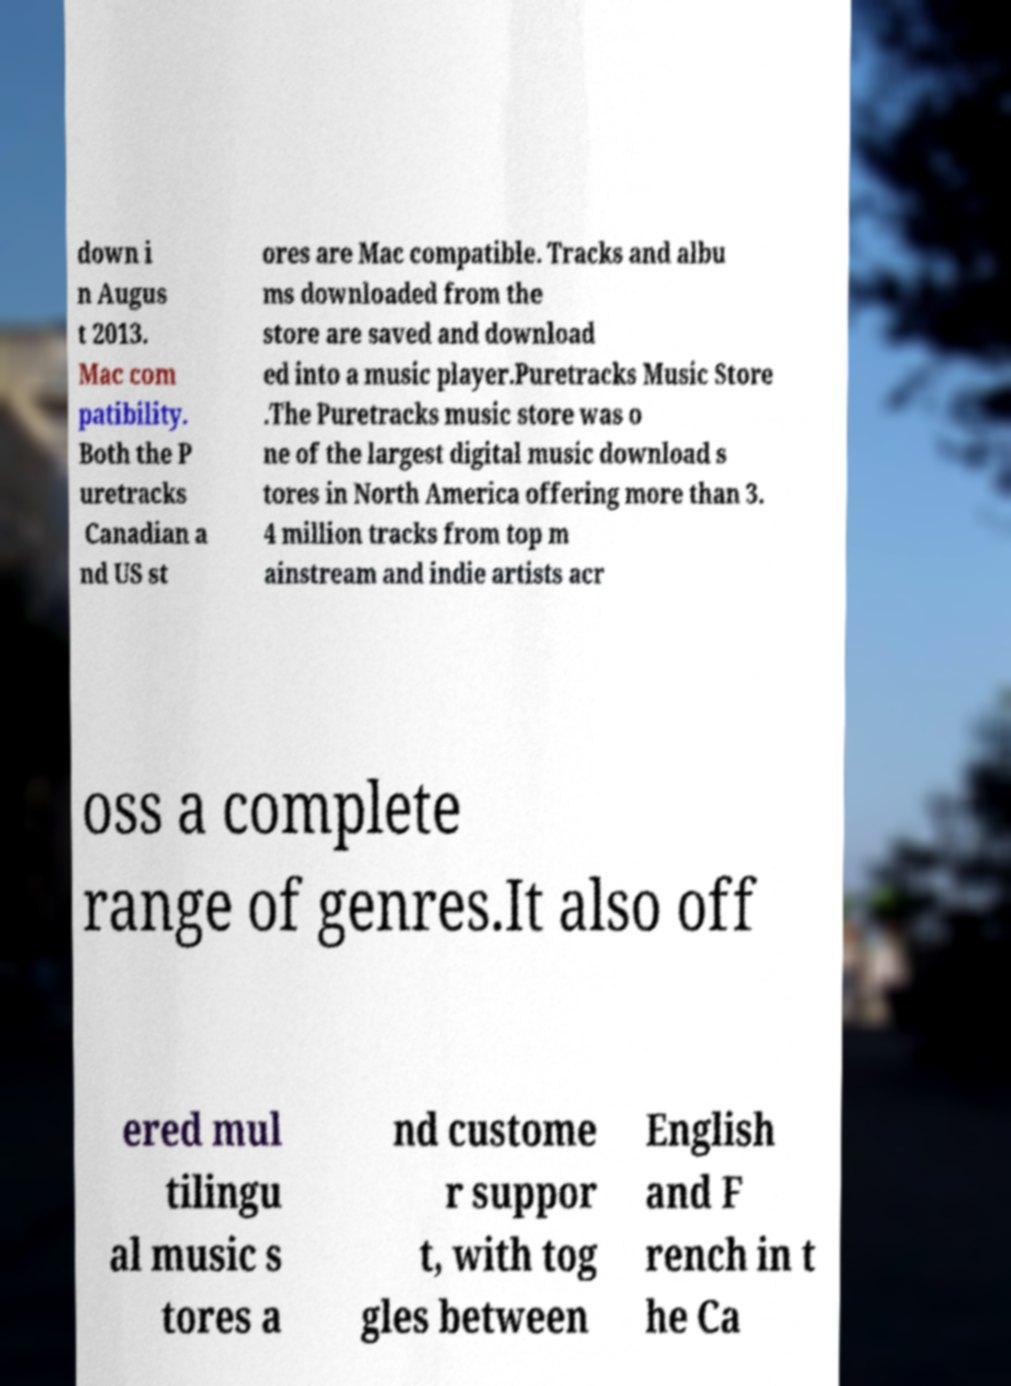Please identify and transcribe the text found in this image. down i n Augus t 2013. Mac com patibility. Both the P uretracks Canadian a nd US st ores are Mac compatible. Tracks and albu ms downloaded from the store are saved and download ed into a music player.Puretracks Music Store .The Puretracks music store was o ne of the largest digital music download s tores in North America offering more than 3. 4 million tracks from top m ainstream and indie artists acr oss a complete range of genres.It also off ered mul tilingu al music s tores a nd custome r suppor t, with tog gles between English and F rench in t he Ca 